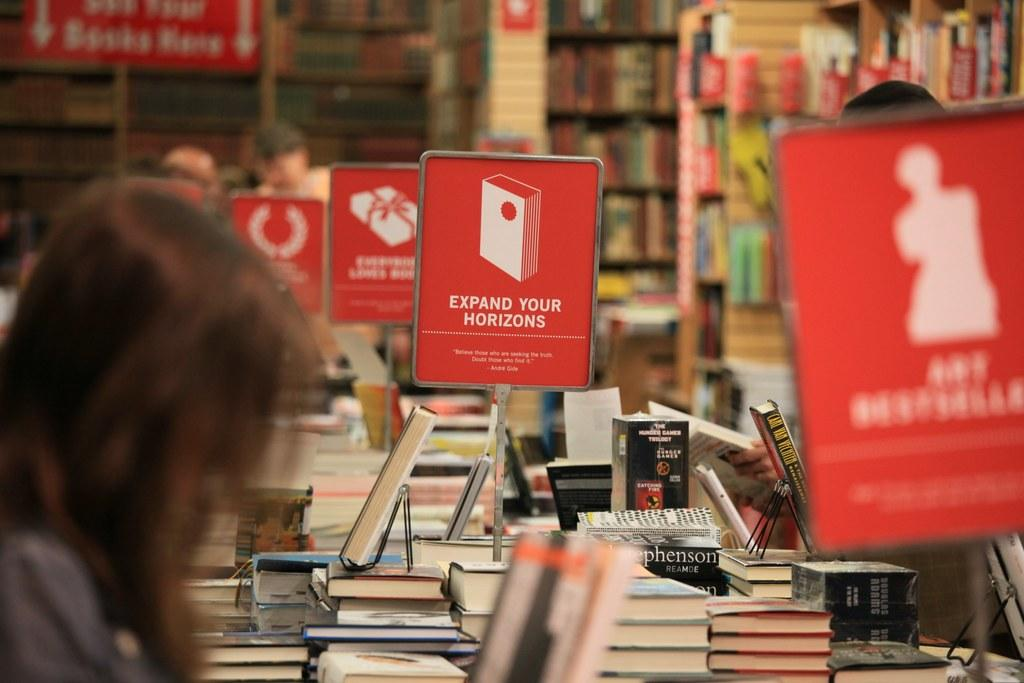<image>
Create a compact narrative representing the image presented. Woman in a library that has lots of books around her, saying Expand your Horizons. 